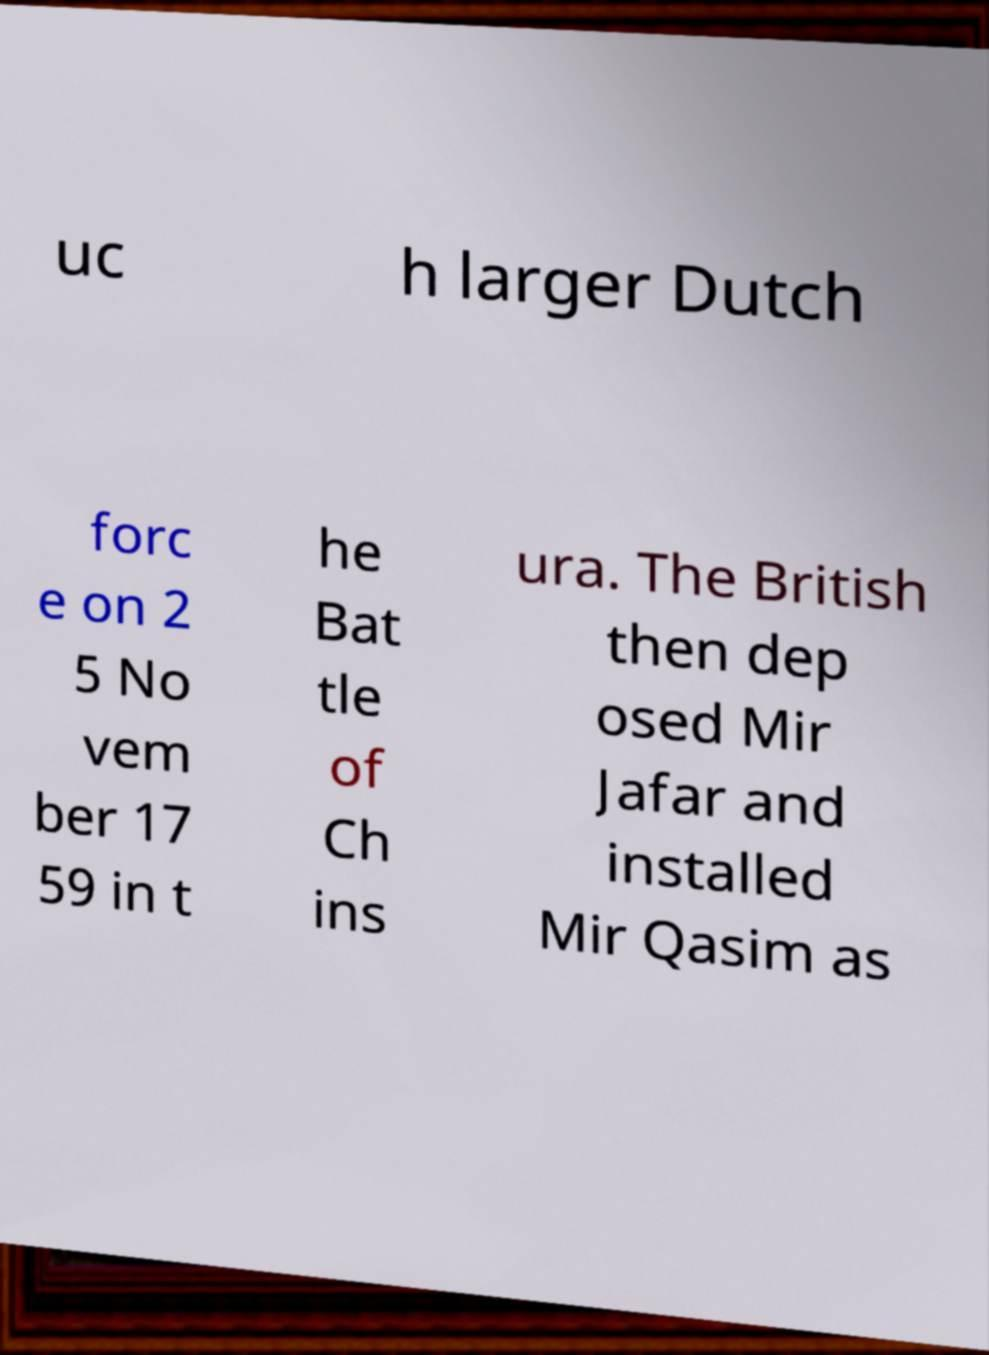Could you assist in decoding the text presented in this image and type it out clearly? uc h larger Dutch forc e on 2 5 No vem ber 17 59 in t he Bat tle of Ch ins ura. The British then dep osed Mir Jafar and installed Mir Qasim as 